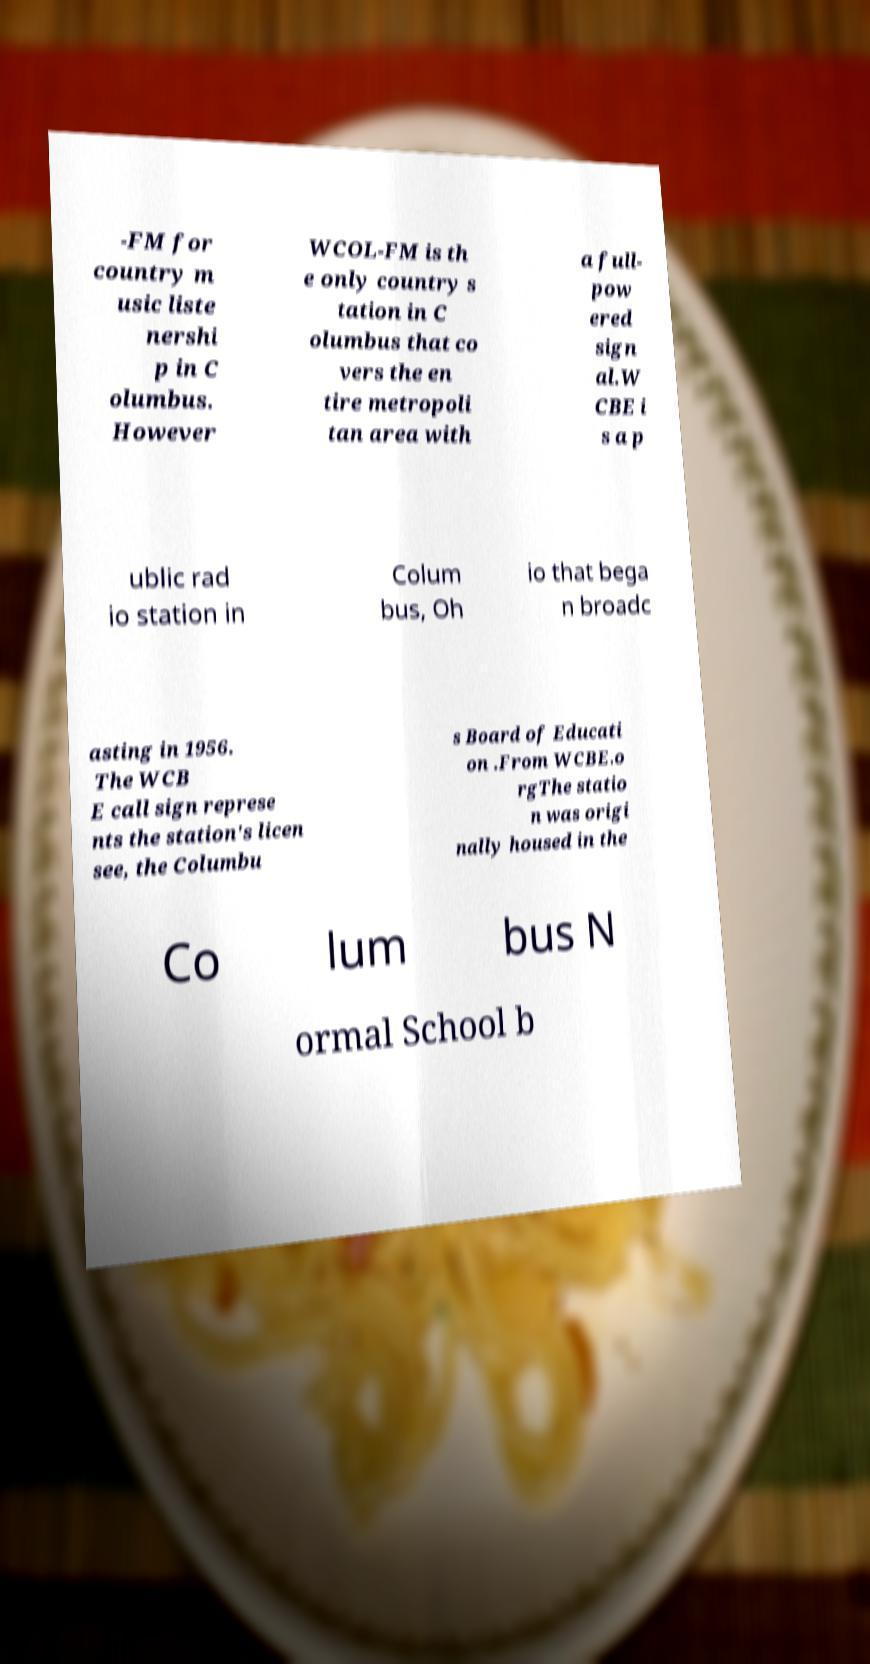Could you extract and type out the text from this image? -FM for country m usic liste nershi p in C olumbus. However WCOL-FM is th e only country s tation in C olumbus that co vers the en tire metropoli tan area with a full- pow ered sign al.W CBE i s a p ublic rad io station in Colum bus, Oh io that bega n broadc asting in 1956. The WCB E call sign represe nts the station's licen see, the Columbu s Board of Educati on .From WCBE.o rgThe statio n was origi nally housed in the Co lum bus N ormal School b 